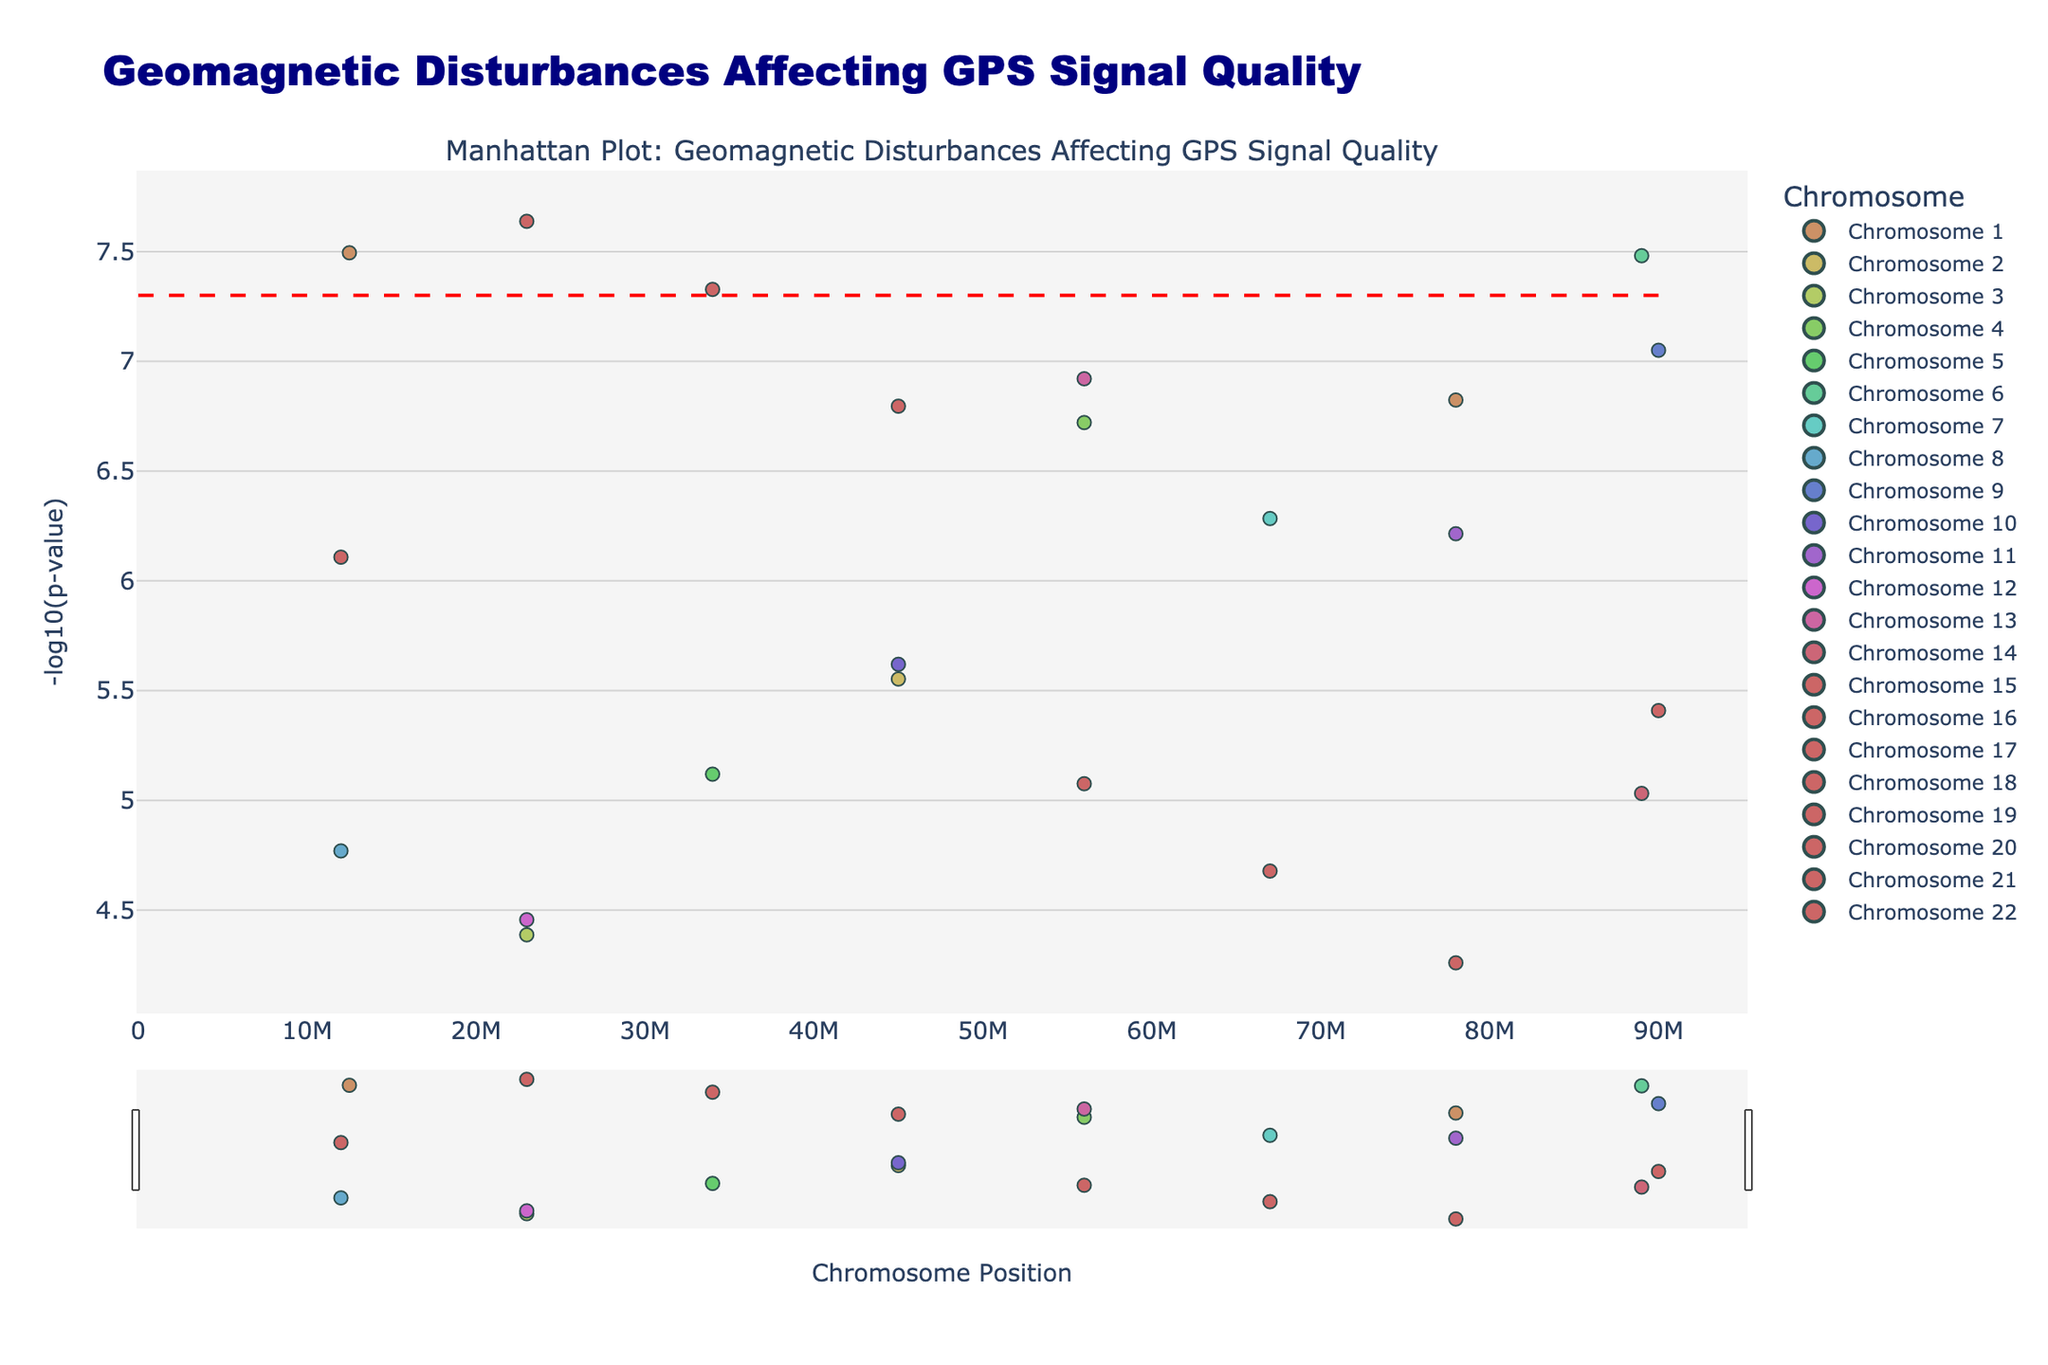What's the title of the plot? The title is displayed at the top of the plot. It reads "Geomagnetic Disturbances Affecting GPS Signal Quality".
Answer: Geomagnetic Disturbances Affecting GPS Signal Quality What does the x-axis represent? The label along the x-axis indicates that it represents "Chromosome Position".
Answer: Chromosome Position What does the y-axis represent? The label along the y-axis indicates that it represents "-log10(p-value)".
Answer: -log10(p-value) Which chromosome has the point with the highest -log10(p-value)? To find the chromosome with the highest -log10(p-value), identify the point with the highest y-value and look at its chromosome label. Chromosome 1 has such a point.
Answer: Chromosome 1 Which location corresponds to the most statistically significant point? The most statistically significant point is the one with the lowest p-value, corresponding to the highest -log10(p-value). The plot shows this point is in Fairbanks.
Answer: Fairbanks How many chromosomes have points above the significance line? The significance line is at -log10(5e-8). Count the chromosomes with points above this line by looking at the y-axis values. There are points from Chromosomes 1, 6, 9, 15, and 21 above this line.
Answer: 5 chromosomes Does any point from Chromosome 10 exceed the significance threshold set at -log10(5e-8)? Check for points on Chromosome 10 and see if any exceed the significance threshold line. No points on Chromosome 10 are above this threshold.
Answer: No Which chromosome has the widest spread of points along the x-axis? Observe the span of points on the x-axis within each chromosome group. Chromosome 1 has a wide spread of points from about 12,500,000 to 78,000,000.
Answer: Chromosome 1 Compare the -log10(p-value) of the points from Fairbanks and Oslo. Which is higher? Look at the points corresponding to Fairbanks and Oslo and compare their y-values. Fairbanks has a higher -log10(p-value) than Oslo.
Answer: Fairbanks 